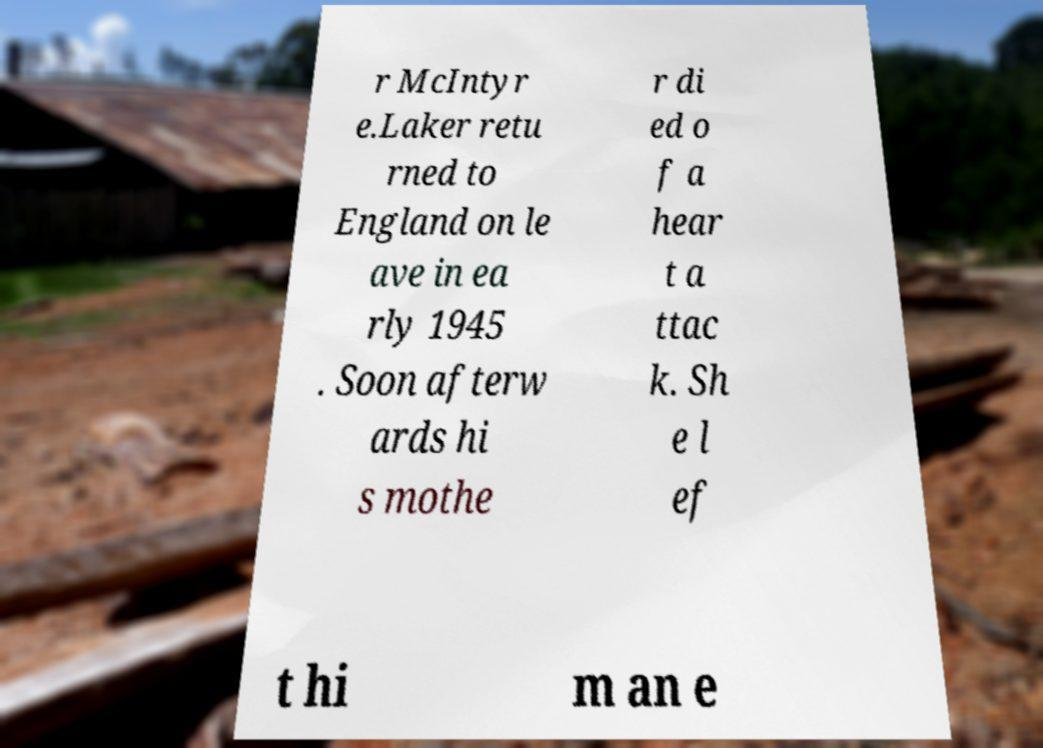Can you accurately transcribe the text from the provided image for me? r McIntyr e.Laker retu rned to England on le ave in ea rly 1945 . Soon afterw ards hi s mothe r di ed o f a hear t a ttac k. Sh e l ef t hi m an e 